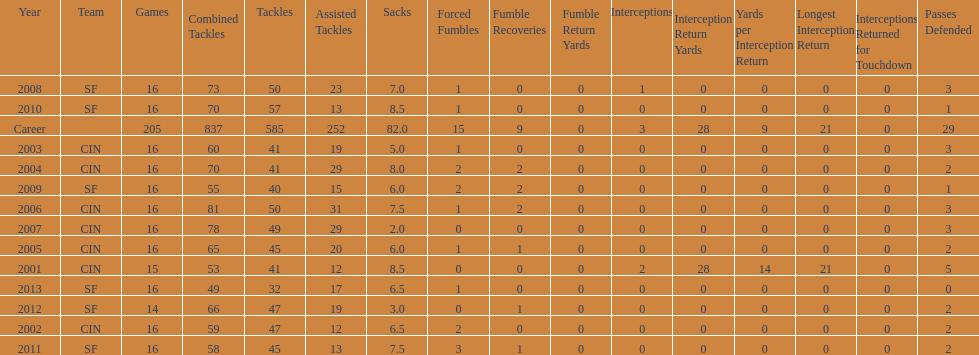How many seasons had combined tackles of 70 or more? 5. 